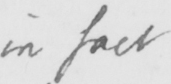Please provide the text content of this handwritten line. in fact 